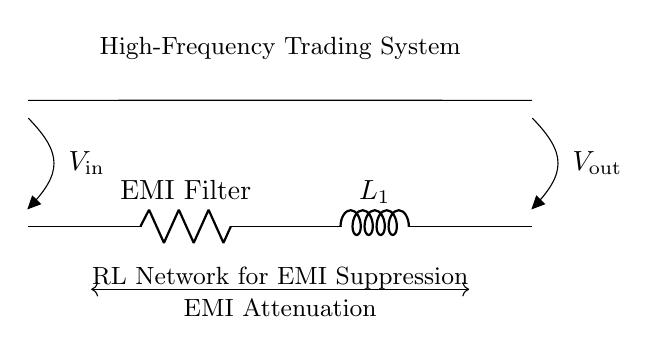What type of components are in this circuit? The circuit consists of a resistor and an inductor, identified as R1 and L1 respectively. These components perform the function of an EMI filter.
Answer: Resistor and Inductor What is the function of R1 in this circuit? R1 acts as an EMI filter, which helps to attenuate unwanted electromagnetic interference in high-frequency signals.
Answer: EMI Filter What is the voltage input denoted as in the diagram? The input voltage is indicated as V_in at the left side of the circuit, specifying where the signal enters the RL network.
Answer: V_in How does this RL network affect EMI? The RL network composed of the resistor (R1) and inductor (L1) works together to filter out high-frequency noise, thereby reducing EMI in the circuit.
Answer: EMI Attenuation What happens to V_out in high-frequency conditions? Under high-frequency conditions, the inductor L1 will react by opposing rapid changes in current, which can lead to a drop in V_out when EMI is significantly attenuated.
Answer: Reduced V_out What is the purpose of the connection between R1 and L1? The connection between R1 and L1 is critical for creating a low-pass filter effect, allowing desired signals to pass while blocking high-frequency noise.
Answer: Low-Pass Filter 